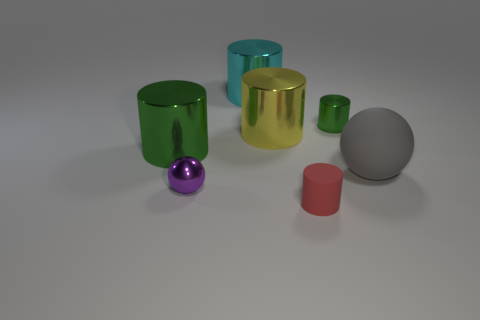Subtract all big yellow cylinders. How many cylinders are left? 4 Add 1 big brown spheres. How many objects exist? 8 Subtract all yellow cylinders. How many cylinders are left? 4 Subtract 4 cylinders. How many cylinders are left? 1 Add 2 cylinders. How many cylinders are left? 7 Add 5 large cyan cylinders. How many large cyan cylinders exist? 6 Subtract 1 green cylinders. How many objects are left? 6 Subtract all cylinders. How many objects are left? 2 Subtract all green cylinders. Subtract all brown cubes. How many cylinders are left? 3 Subtract all yellow cylinders. How many gray balls are left? 1 